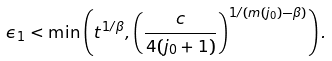Convert formula to latex. <formula><loc_0><loc_0><loc_500><loc_500>\epsilon _ { 1 } < \min \left ( t ^ { 1 / \beta } , \left ( \frac { c } { 4 ( j _ { 0 } + 1 ) } \right ) ^ { 1 / ( m ( j _ { 0 } ) - \beta ) } \right ) .</formula> 